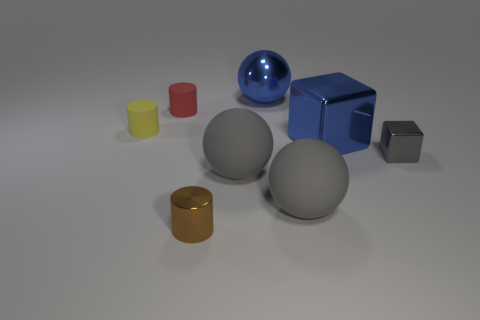Add 1 big rubber things. How many objects exist? 9 Subtract all spheres. How many objects are left? 5 Add 5 large cubes. How many large cubes exist? 6 Subtract 0 cyan spheres. How many objects are left? 8 Subtract all tiny gray metal blocks. Subtract all brown metal cylinders. How many objects are left? 6 Add 1 small gray shiny blocks. How many small gray shiny blocks are left? 2 